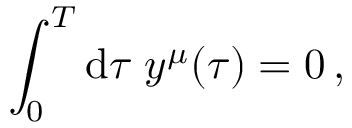<formula> <loc_0><loc_0><loc_500><loc_500>\int _ { 0 } ^ { T } d \tau \, y ^ { \mu } ( \tau ) = 0 \, ,</formula> 